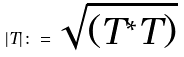Convert formula to latex. <formula><loc_0><loc_0><loc_500><loc_500>| T | \colon = \sqrt { ( T ^ { * } T ) }</formula> 